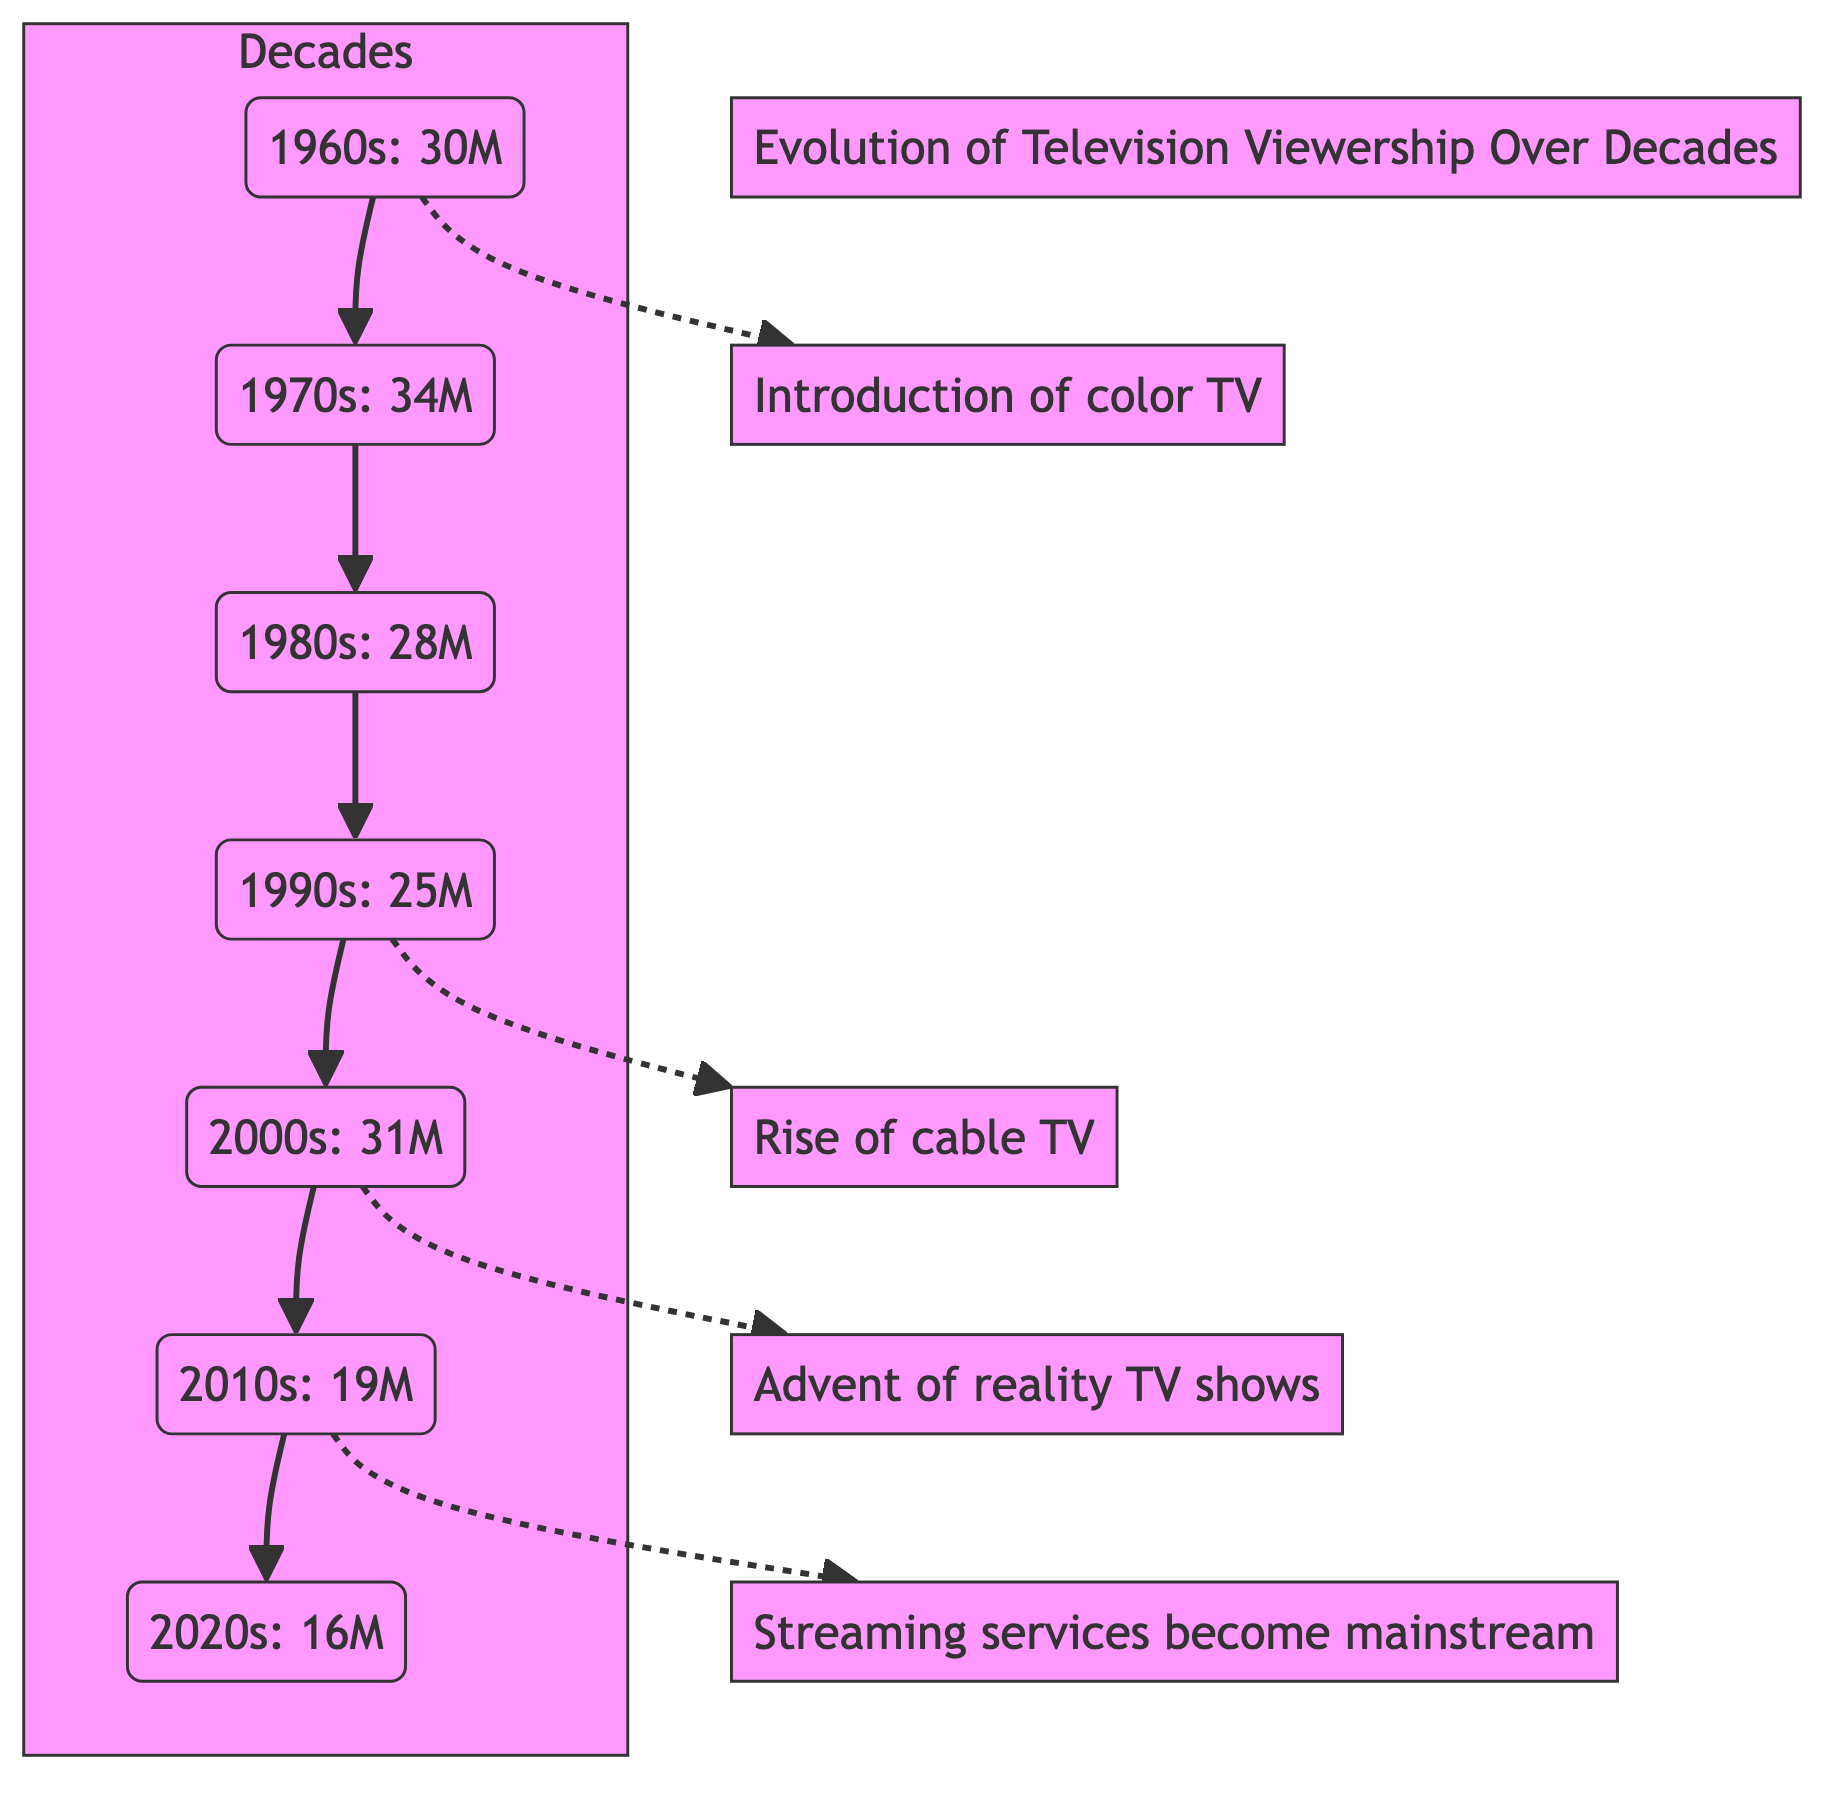What was the viewership in the 1970s? The diagram indicates that the viewership in the 1970s was 34 million. This information is clearly labeled next to the 1970s node in the diagram.
Answer: 34M What decade saw the lowest viewer ratings? By examining the viewer ratings for each decade listed in the diagram, it is clear that the 2020s had the lowest viewer ratings, which were 16 million. This is the minimum value shown in the diagram.
Answer: 2020s Which decade had the highest viewership? The diagram shows that the 1960s had the highest viewership at 30 million, making it the decade with the largest viewer count. This is found directly on the 1960s node.
Answer: 1960s How did viewership change from the 1980s to the 1990s? The transition from the 1980s to the 1990s shows a decline, with the 1980s having 28 million viewers and the 1990s dropping to 25 million viewers. This indicates a decrease in views from one decade to the next.
Answer: Decrease What significant event relates to the 1990s in the context of television? The diagram indicates that the rise of cable TV occurred in the 1990s. This information helps contextualize the viewer rating changes happening during that decade.
Answer: Rise of cable TV What was the general trend in viewership from the 1980s to the 2020s? Analyzing the nodes, the trend shows a consistent decline in viewer ratings, going from 28 million in the 1980s down to 16 million in the 2020s. This decline can be traced chronologically through the decade nodes in the diagram.
Answer: Decline How many nodes represent decades in the diagram? The diagram presents a total of seven nodes that represent the decades from the 1960s to the 2020s, each labeled with its respective viewership. The count comes from simply counting the decade nodes in sequence.
Answer: 7 What major television event is associated with the introduction of color TV? In the diagram, the introduction of color TV is linked to the 1960s. This is indicated by a dotted line that connects the 1960s node to the Color TV node, signifying its importance during that time.
Answer: Introduction of color TV How many viewership milestones are illustrated apart from the decade nodes? There are four significant milestones in the form of major events related to television that are illustrated aside from the decade nodes, specifically color TV, cable TV, reality TV, and streaming services. This can be confirmed by counting the relevant milestone nodes in the diagram.
Answer: 4 